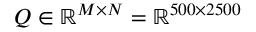<formula> <loc_0><loc_0><loc_500><loc_500>Q \in \mathbb { R } ^ { M \times N } = \mathbb { R } ^ { 5 0 0 \times 2 5 0 0 }</formula> 